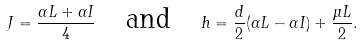Convert formula to latex. <formula><loc_0><loc_0><loc_500><loc_500>J = \frac { \alpha L + \alpha I } 4 \quad \text {and} \quad h = \frac { d } { 2 } ( \alpha L - \alpha I ) + \frac { \mu L } 2 .</formula> 